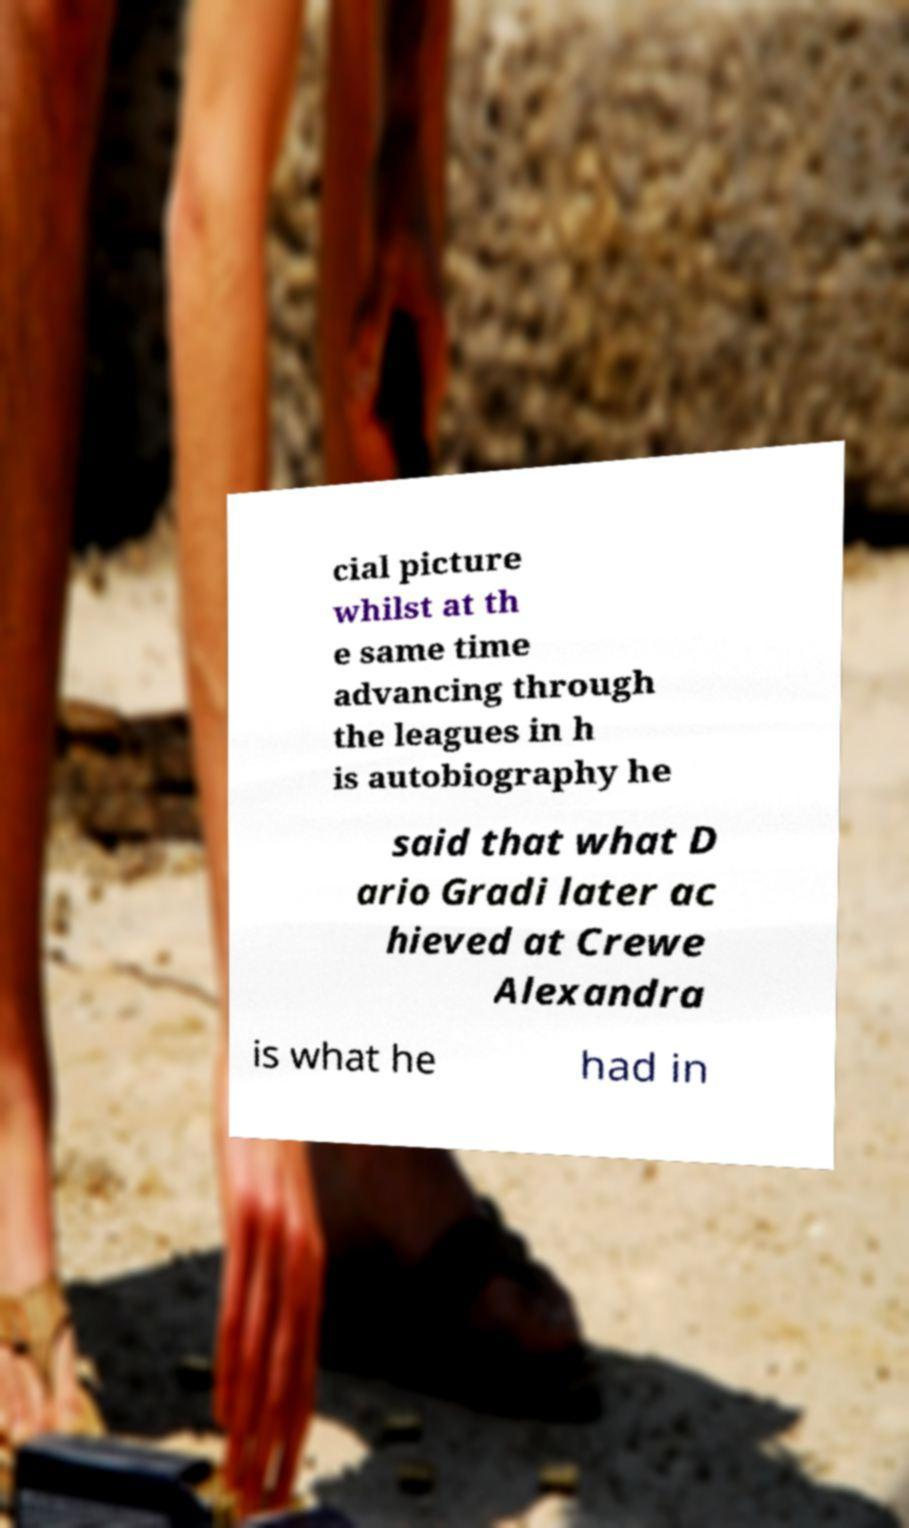Could you extract and type out the text from this image? cial picture whilst at th e same time advancing through the leagues in h is autobiography he said that what D ario Gradi later ac hieved at Crewe Alexandra is what he had in 